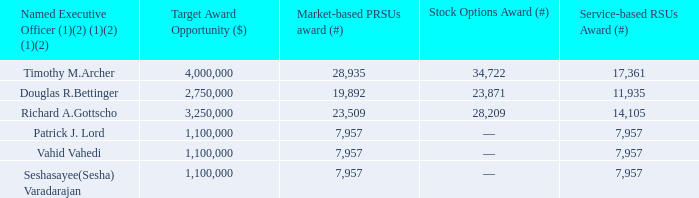Figure 29. 2016/2018 LTIP Award Grants
(1) All of the Market-based PRSUs and one-third of the stock options and service-based RSUs granted to Mr. Anstice under the 2016/2018 LTIP that were scheduled to vest in February 2019 were canceled upon his termination of employment with the Company as of December 5, 2018.
(2) The number of Market-based PRSUs awarded is reflected at target. The final number of shares that may have been earned is 0% to 150% of target.
In February 2019, the committee determined the payouts for the calendar year 2016/2018 LTIP Awards of Market-based PRSUs. The number of shares represented by the Marketbased PRSUs earned over the performance period was based on our stock price performance compared to the market price performance of the SOX index.
Based on the above formula and Market-based PRSU Vesting Summary set forth in Figures 26 and 27, the Company’s stock price performance over the three-year performance period was equal to 89.93% and performance of the SOX index (based on market price) over the same three-year performance period was equal to 84.47%. Lam’s stock price outperformed the SOX index by 5.46%, which resulted in a performance payout of 110.93% to target number of Marketbased PRSUs granted to each NEO. Based on such results, the committee made the following payouts to each NEO for the 2016/2018 LTIP Award of Market-based PRSUs.
What was the number of shares represented by the Marketbased PRSUs earned over the performance period based on? Our stock price performance compared to the market price performance of the sox index. What was the Company's stock price performance over the three-year performance period? 89.93%. How much did Lam's stock price outperform the SOX index by? 5.46%. Which named executive officer has the highest target award opportunity? Find the named executive officer with the highest target award opportunity
Answer: timothy m.archer. Which named executive officer has the highest Market-based PRSUs award? Find the named executive officer with the highest Market-based PRSUs award
Answer: timothy m.archer. Which named executive officer has the highest Stock Options Award? Find the named executive officer with the highest Stock Options Award
Answer: timothy m.archer. 